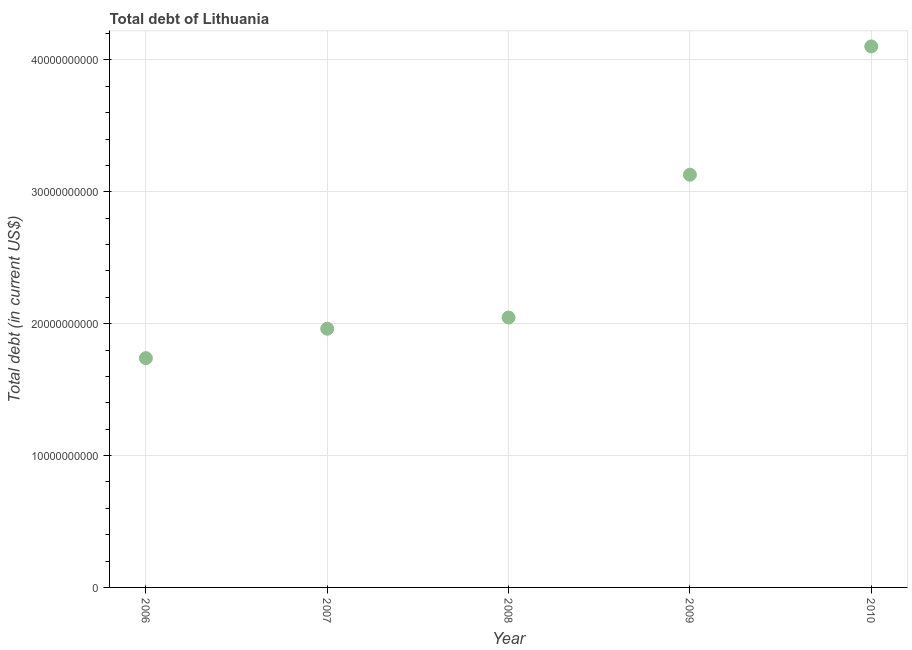What is the total debt in 2010?
Make the answer very short. 4.10e+1. Across all years, what is the maximum total debt?
Offer a very short reply. 4.10e+1. Across all years, what is the minimum total debt?
Your response must be concise. 1.74e+1. In which year was the total debt maximum?
Your answer should be very brief. 2010. In which year was the total debt minimum?
Give a very brief answer. 2006. What is the sum of the total debt?
Your answer should be very brief. 1.30e+11. What is the difference between the total debt in 2007 and 2009?
Keep it short and to the point. -1.17e+1. What is the average total debt per year?
Keep it short and to the point. 2.60e+1. What is the median total debt?
Give a very brief answer. 2.05e+1. In how many years, is the total debt greater than 34000000000 US$?
Make the answer very short. 1. What is the ratio of the total debt in 2006 to that in 2008?
Your answer should be compact. 0.85. What is the difference between the highest and the second highest total debt?
Ensure brevity in your answer.  9.73e+09. What is the difference between the highest and the lowest total debt?
Your response must be concise. 2.36e+1. In how many years, is the total debt greater than the average total debt taken over all years?
Keep it short and to the point. 2. How many dotlines are there?
Your response must be concise. 1. How many years are there in the graph?
Provide a succinct answer. 5. What is the difference between two consecutive major ticks on the Y-axis?
Give a very brief answer. 1.00e+1. What is the title of the graph?
Keep it short and to the point. Total debt of Lithuania. What is the label or title of the X-axis?
Your answer should be compact. Year. What is the label or title of the Y-axis?
Ensure brevity in your answer.  Total debt (in current US$). What is the Total debt (in current US$) in 2006?
Your answer should be compact. 1.74e+1. What is the Total debt (in current US$) in 2007?
Make the answer very short. 1.96e+1. What is the Total debt (in current US$) in 2008?
Offer a very short reply. 2.05e+1. What is the Total debt (in current US$) in 2009?
Your response must be concise. 3.13e+1. What is the Total debt (in current US$) in 2010?
Your answer should be compact. 4.10e+1. What is the difference between the Total debt (in current US$) in 2006 and 2007?
Offer a very short reply. -2.23e+09. What is the difference between the Total debt (in current US$) in 2006 and 2008?
Give a very brief answer. -3.08e+09. What is the difference between the Total debt (in current US$) in 2006 and 2009?
Your response must be concise. -1.39e+1. What is the difference between the Total debt (in current US$) in 2006 and 2010?
Ensure brevity in your answer.  -2.36e+1. What is the difference between the Total debt (in current US$) in 2007 and 2008?
Make the answer very short. -8.50e+08. What is the difference between the Total debt (in current US$) in 2007 and 2009?
Your answer should be compact. -1.17e+1. What is the difference between the Total debt (in current US$) in 2007 and 2010?
Offer a very short reply. -2.14e+1. What is the difference between the Total debt (in current US$) in 2008 and 2009?
Make the answer very short. -1.08e+1. What is the difference between the Total debt (in current US$) in 2008 and 2010?
Your answer should be compact. -2.06e+1. What is the difference between the Total debt (in current US$) in 2009 and 2010?
Keep it short and to the point. -9.73e+09. What is the ratio of the Total debt (in current US$) in 2006 to that in 2007?
Your response must be concise. 0.89. What is the ratio of the Total debt (in current US$) in 2006 to that in 2009?
Give a very brief answer. 0.56. What is the ratio of the Total debt (in current US$) in 2006 to that in 2010?
Offer a terse response. 0.42. What is the ratio of the Total debt (in current US$) in 2007 to that in 2008?
Offer a terse response. 0.96. What is the ratio of the Total debt (in current US$) in 2007 to that in 2009?
Keep it short and to the point. 0.63. What is the ratio of the Total debt (in current US$) in 2007 to that in 2010?
Make the answer very short. 0.48. What is the ratio of the Total debt (in current US$) in 2008 to that in 2009?
Provide a short and direct response. 0.65. What is the ratio of the Total debt (in current US$) in 2008 to that in 2010?
Ensure brevity in your answer.  0.5. What is the ratio of the Total debt (in current US$) in 2009 to that in 2010?
Your answer should be very brief. 0.76. 